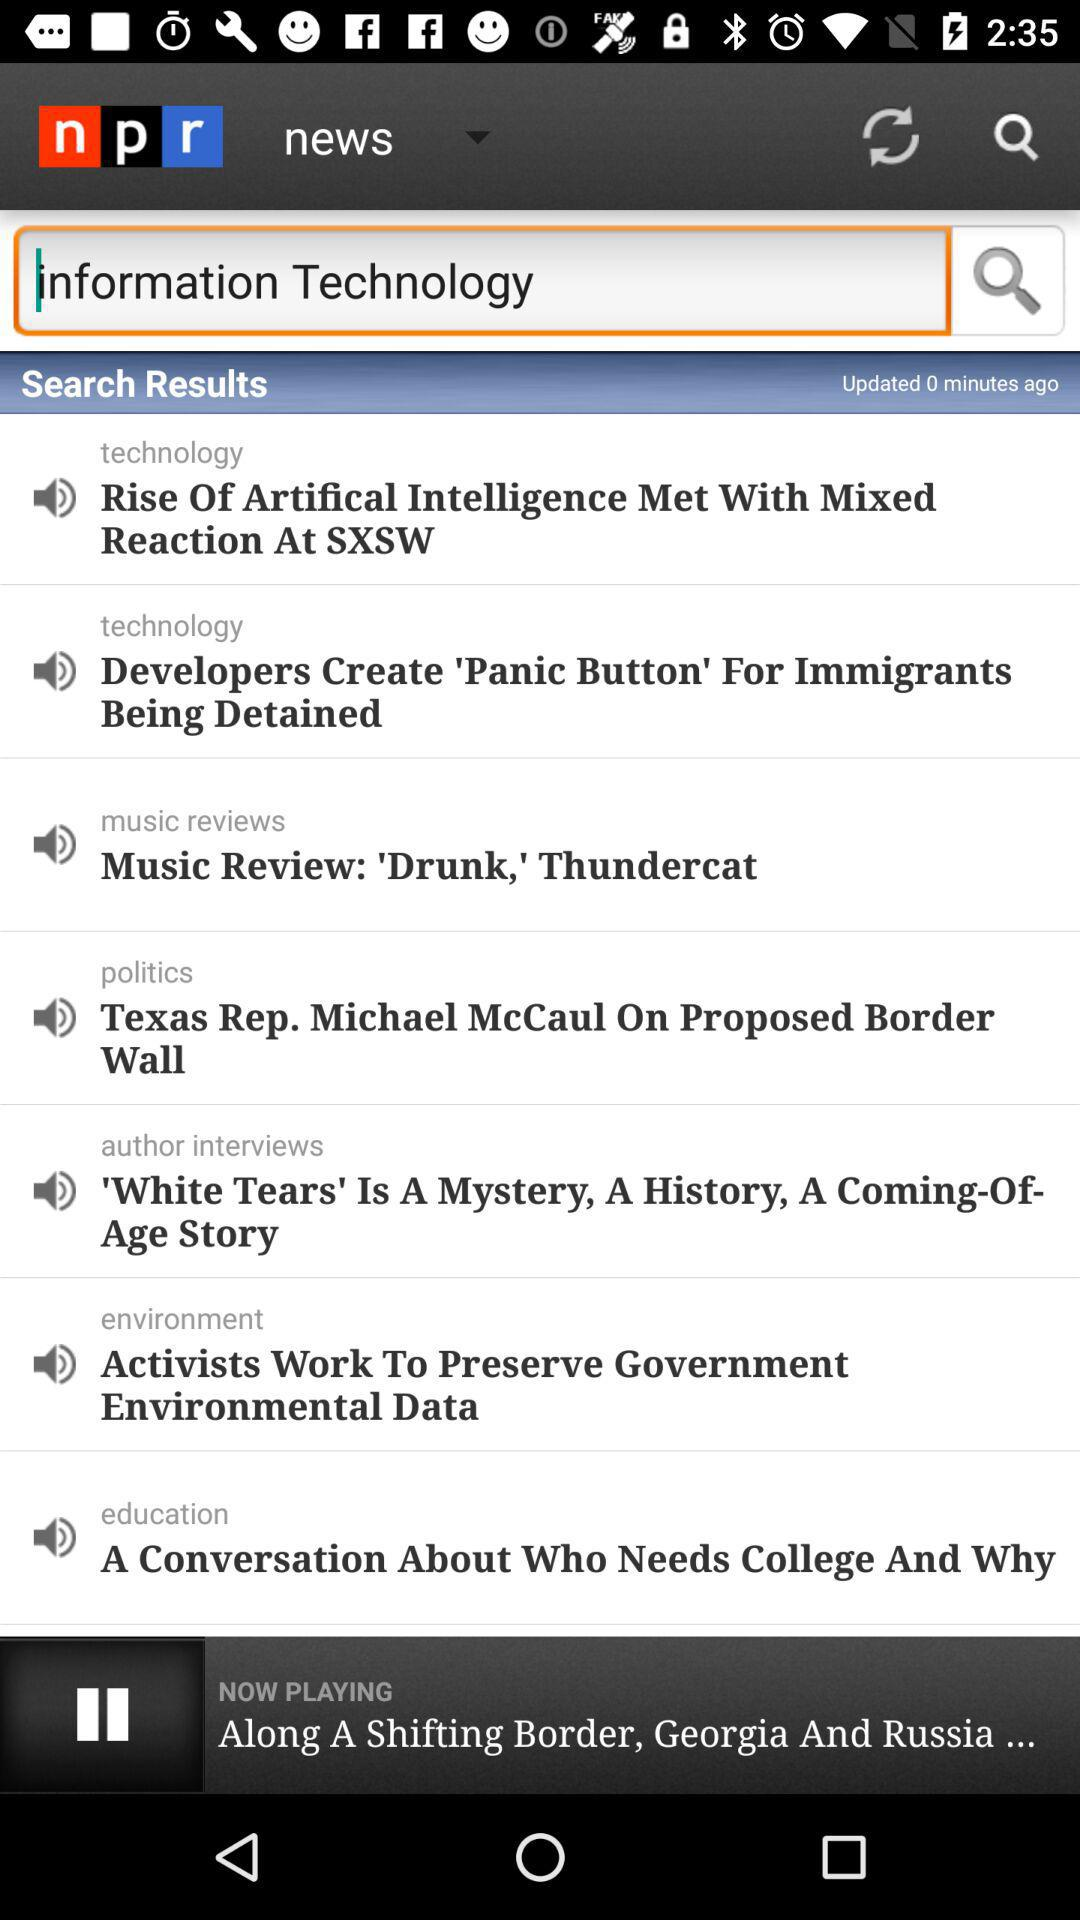Who created the 'Panic button' for immigrants? It was created by developers. 